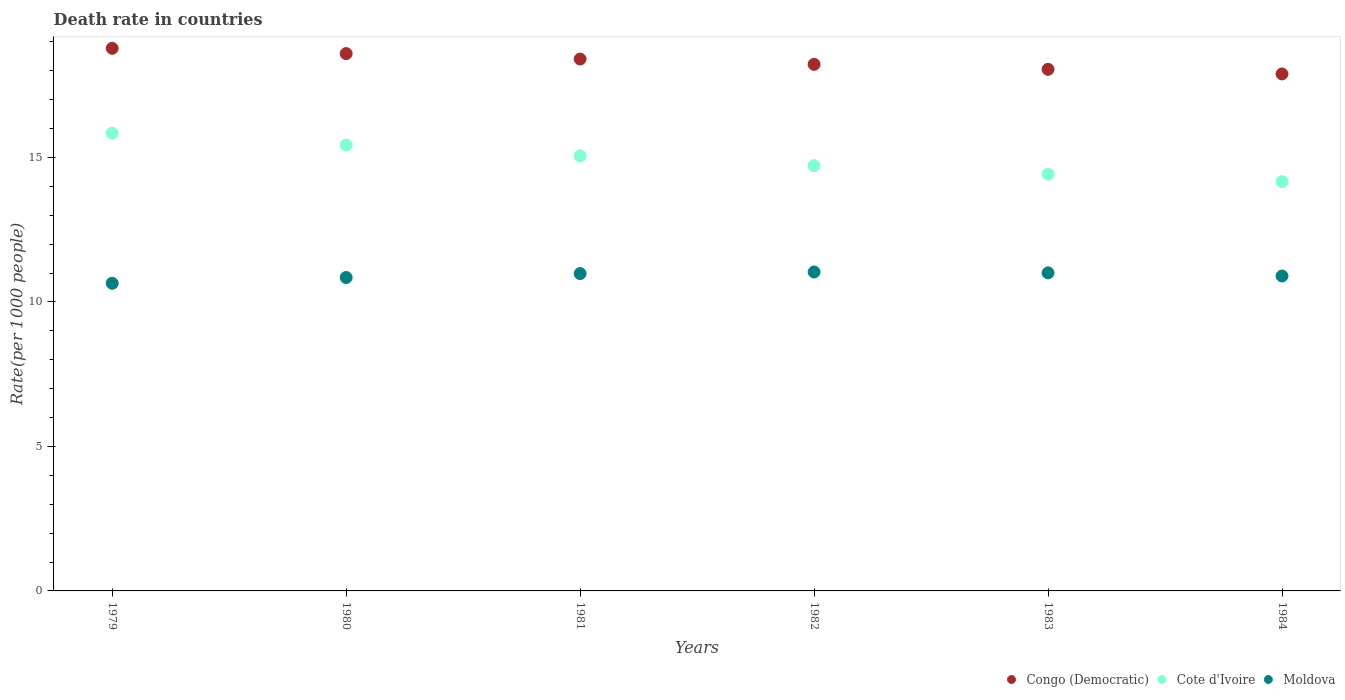How many different coloured dotlines are there?
Offer a very short reply. 3. Across all years, what is the maximum death rate in Congo (Democratic)?
Keep it short and to the point. 18.78. Across all years, what is the minimum death rate in Moldova?
Provide a short and direct response. 10.65. In which year was the death rate in Cote d'Ivoire maximum?
Your response must be concise. 1979. What is the total death rate in Moldova in the graph?
Offer a terse response. 65.43. What is the difference between the death rate in Moldova in 1980 and that in 1982?
Offer a very short reply. -0.19. What is the difference between the death rate in Cote d'Ivoire in 1979 and the death rate in Congo (Democratic) in 1981?
Offer a terse response. -2.57. What is the average death rate in Congo (Democratic) per year?
Provide a succinct answer. 18.33. In the year 1984, what is the difference between the death rate in Moldova and death rate in Congo (Democratic)?
Provide a short and direct response. -6.99. What is the ratio of the death rate in Cote d'Ivoire in 1980 to that in 1981?
Provide a short and direct response. 1.02. Is the difference between the death rate in Moldova in 1981 and 1983 greater than the difference between the death rate in Congo (Democratic) in 1981 and 1983?
Keep it short and to the point. No. What is the difference between the highest and the second highest death rate in Congo (Democratic)?
Offer a very short reply. 0.18. What is the difference between the highest and the lowest death rate in Cote d'Ivoire?
Your answer should be very brief. 1.68. Is it the case that in every year, the sum of the death rate in Congo (Democratic) and death rate in Moldova  is greater than the death rate in Cote d'Ivoire?
Your answer should be compact. Yes. How many dotlines are there?
Make the answer very short. 3. Are the values on the major ticks of Y-axis written in scientific E-notation?
Your response must be concise. No. Does the graph contain grids?
Offer a terse response. No. Where does the legend appear in the graph?
Offer a very short reply. Bottom right. What is the title of the graph?
Give a very brief answer. Death rate in countries. Does "French Polynesia" appear as one of the legend labels in the graph?
Your answer should be very brief. No. What is the label or title of the Y-axis?
Your answer should be compact. Rate(per 1000 people). What is the Rate(per 1000 people) in Congo (Democratic) in 1979?
Your response must be concise. 18.78. What is the Rate(per 1000 people) of Cote d'Ivoire in 1979?
Your answer should be very brief. 15.84. What is the Rate(per 1000 people) of Moldova in 1979?
Your answer should be very brief. 10.65. What is the Rate(per 1000 people) in Congo (Democratic) in 1980?
Provide a succinct answer. 18.6. What is the Rate(per 1000 people) in Cote d'Ivoire in 1980?
Keep it short and to the point. 15.43. What is the Rate(per 1000 people) in Moldova in 1980?
Your response must be concise. 10.85. What is the Rate(per 1000 people) in Congo (Democratic) in 1981?
Offer a very short reply. 18.41. What is the Rate(per 1000 people) in Cote d'Ivoire in 1981?
Make the answer very short. 15.06. What is the Rate(per 1000 people) of Moldova in 1981?
Offer a terse response. 10.98. What is the Rate(per 1000 people) in Congo (Democratic) in 1982?
Ensure brevity in your answer.  18.23. What is the Rate(per 1000 people) of Cote d'Ivoire in 1982?
Your answer should be compact. 14.72. What is the Rate(per 1000 people) of Moldova in 1982?
Your answer should be compact. 11.04. What is the Rate(per 1000 people) in Congo (Democratic) in 1983?
Provide a short and direct response. 18.05. What is the Rate(per 1000 people) in Cote d'Ivoire in 1983?
Make the answer very short. 14.42. What is the Rate(per 1000 people) in Moldova in 1983?
Offer a terse response. 11.01. What is the Rate(per 1000 people) in Congo (Democratic) in 1984?
Offer a very short reply. 17.89. What is the Rate(per 1000 people) of Cote d'Ivoire in 1984?
Make the answer very short. 14.16. Across all years, what is the maximum Rate(per 1000 people) in Congo (Democratic)?
Your answer should be compact. 18.78. Across all years, what is the maximum Rate(per 1000 people) of Cote d'Ivoire?
Offer a terse response. 15.84. Across all years, what is the maximum Rate(per 1000 people) in Moldova?
Your response must be concise. 11.04. Across all years, what is the minimum Rate(per 1000 people) in Congo (Democratic)?
Provide a short and direct response. 17.89. Across all years, what is the minimum Rate(per 1000 people) of Cote d'Ivoire?
Your response must be concise. 14.16. Across all years, what is the minimum Rate(per 1000 people) in Moldova?
Your answer should be very brief. 10.65. What is the total Rate(per 1000 people) of Congo (Democratic) in the graph?
Keep it short and to the point. 109.96. What is the total Rate(per 1000 people) in Cote d'Ivoire in the graph?
Your answer should be compact. 89.64. What is the total Rate(per 1000 people) in Moldova in the graph?
Make the answer very short. 65.43. What is the difference between the Rate(per 1000 people) of Congo (Democratic) in 1979 and that in 1980?
Provide a succinct answer. 0.18. What is the difference between the Rate(per 1000 people) of Cote d'Ivoire in 1979 and that in 1980?
Make the answer very short. 0.41. What is the difference between the Rate(per 1000 people) of Moldova in 1979 and that in 1980?
Offer a very short reply. -0.2. What is the difference between the Rate(per 1000 people) in Congo (Democratic) in 1979 and that in 1981?
Keep it short and to the point. 0.37. What is the difference between the Rate(per 1000 people) in Cote d'Ivoire in 1979 and that in 1981?
Keep it short and to the point. 0.78. What is the difference between the Rate(per 1000 people) in Moldova in 1979 and that in 1981?
Provide a succinct answer. -0.34. What is the difference between the Rate(per 1000 people) of Congo (Democratic) in 1979 and that in 1982?
Offer a terse response. 0.56. What is the difference between the Rate(per 1000 people) of Cote d'Ivoire in 1979 and that in 1982?
Your answer should be compact. 1.12. What is the difference between the Rate(per 1000 people) in Moldova in 1979 and that in 1982?
Provide a short and direct response. -0.39. What is the difference between the Rate(per 1000 people) of Congo (Democratic) in 1979 and that in 1983?
Provide a short and direct response. 0.73. What is the difference between the Rate(per 1000 people) of Cote d'Ivoire in 1979 and that in 1983?
Provide a short and direct response. 1.42. What is the difference between the Rate(per 1000 people) in Moldova in 1979 and that in 1983?
Your answer should be compact. -0.36. What is the difference between the Rate(per 1000 people) of Congo (Democratic) in 1979 and that in 1984?
Provide a short and direct response. 0.89. What is the difference between the Rate(per 1000 people) of Cote d'Ivoire in 1979 and that in 1984?
Your response must be concise. 1.68. What is the difference between the Rate(per 1000 people) in Moldova in 1979 and that in 1984?
Provide a succinct answer. -0.25. What is the difference between the Rate(per 1000 people) of Congo (Democratic) in 1980 and that in 1981?
Offer a very short reply. 0.19. What is the difference between the Rate(per 1000 people) of Cote d'Ivoire in 1980 and that in 1981?
Give a very brief answer. 0.37. What is the difference between the Rate(per 1000 people) of Moldova in 1980 and that in 1981?
Keep it short and to the point. -0.14. What is the difference between the Rate(per 1000 people) of Congo (Democratic) in 1980 and that in 1982?
Offer a very short reply. 0.37. What is the difference between the Rate(per 1000 people) of Cote d'Ivoire in 1980 and that in 1982?
Your answer should be very brief. 0.71. What is the difference between the Rate(per 1000 people) of Moldova in 1980 and that in 1982?
Keep it short and to the point. -0.19. What is the difference between the Rate(per 1000 people) of Congo (Democratic) in 1980 and that in 1983?
Offer a very short reply. 0.54. What is the difference between the Rate(per 1000 people) in Cote d'Ivoire in 1980 and that in 1983?
Offer a terse response. 1.01. What is the difference between the Rate(per 1000 people) in Moldova in 1980 and that in 1983?
Make the answer very short. -0.16. What is the difference between the Rate(per 1000 people) in Congo (Democratic) in 1980 and that in 1984?
Give a very brief answer. 0.7. What is the difference between the Rate(per 1000 people) of Cote d'Ivoire in 1980 and that in 1984?
Provide a short and direct response. 1.27. What is the difference between the Rate(per 1000 people) of Moldova in 1980 and that in 1984?
Offer a terse response. -0.05. What is the difference between the Rate(per 1000 people) in Congo (Democratic) in 1981 and that in 1982?
Your answer should be very brief. 0.18. What is the difference between the Rate(per 1000 people) in Cote d'Ivoire in 1981 and that in 1982?
Keep it short and to the point. 0.34. What is the difference between the Rate(per 1000 people) in Moldova in 1981 and that in 1982?
Your response must be concise. -0.06. What is the difference between the Rate(per 1000 people) in Congo (Democratic) in 1981 and that in 1983?
Provide a succinct answer. 0.36. What is the difference between the Rate(per 1000 people) of Cote d'Ivoire in 1981 and that in 1983?
Provide a succinct answer. 0.64. What is the difference between the Rate(per 1000 people) of Moldova in 1981 and that in 1983?
Offer a terse response. -0.03. What is the difference between the Rate(per 1000 people) in Congo (Democratic) in 1981 and that in 1984?
Offer a very short reply. 0.52. What is the difference between the Rate(per 1000 people) of Cote d'Ivoire in 1981 and that in 1984?
Provide a short and direct response. 0.89. What is the difference between the Rate(per 1000 people) of Moldova in 1981 and that in 1984?
Ensure brevity in your answer.  0.08. What is the difference between the Rate(per 1000 people) of Congo (Democratic) in 1982 and that in 1983?
Offer a very short reply. 0.17. What is the difference between the Rate(per 1000 people) of Cote d'Ivoire in 1982 and that in 1983?
Provide a short and direct response. 0.3. What is the difference between the Rate(per 1000 people) of Moldova in 1982 and that in 1983?
Give a very brief answer. 0.03. What is the difference between the Rate(per 1000 people) in Congo (Democratic) in 1982 and that in 1984?
Ensure brevity in your answer.  0.33. What is the difference between the Rate(per 1000 people) in Cote d'Ivoire in 1982 and that in 1984?
Your response must be concise. 0.56. What is the difference between the Rate(per 1000 people) of Moldova in 1982 and that in 1984?
Ensure brevity in your answer.  0.14. What is the difference between the Rate(per 1000 people) in Congo (Democratic) in 1983 and that in 1984?
Offer a terse response. 0.16. What is the difference between the Rate(per 1000 people) of Cote d'Ivoire in 1983 and that in 1984?
Keep it short and to the point. 0.26. What is the difference between the Rate(per 1000 people) in Moldova in 1983 and that in 1984?
Provide a short and direct response. 0.11. What is the difference between the Rate(per 1000 people) in Congo (Democratic) in 1979 and the Rate(per 1000 people) in Cote d'Ivoire in 1980?
Make the answer very short. 3.35. What is the difference between the Rate(per 1000 people) of Congo (Democratic) in 1979 and the Rate(per 1000 people) of Moldova in 1980?
Your response must be concise. 7.93. What is the difference between the Rate(per 1000 people) in Cote d'Ivoire in 1979 and the Rate(per 1000 people) in Moldova in 1980?
Offer a very short reply. 4.99. What is the difference between the Rate(per 1000 people) of Congo (Democratic) in 1979 and the Rate(per 1000 people) of Cote d'Ivoire in 1981?
Offer a very short reply. 3.72. What is the difference between the Rate(per 1000 people) of Congo (Democratic) in 1979 and the Rate(per 1000 people) of Moldova in 1981?
Your answer should be very brief. 7.8. What is the difference between the Rate(per 1000 people) in Cote d'Ivoire in 1979 and the Rate(per 1000 people) in Moldova in 1981?
Your response must be concise. 4.86. What is the difference between the Rate(per 1000 people) of Congo (Democratic) in 1979 and the Rate(per 1000 people) of Cote d'Ivoire in 1982?
Keep it short and to the point. 4.06. What is the difference between the Rate(per 1000 people) of Congo (Democratic) in 1979 and the Rate(per 1000 people) of Moldova in 1982?
Keep it short and to the point. 7.74. What is the difference between the Rate(per 1000 people) of Cote d'Ivoire in 1979 and the Rate(per 1000 people) of Moldova in 1982?
Offer a very short reply. 4.8. What is the difference between the Rate(per 1000 people) in Congo (Democratic) in 1979 and the Rate(per 1000 people) in Cote d'Ivoire in 1983?
Offer a terse response. 4.36. What is the difference between the Rate(per 1000 people) of Congo (Democratic) in 1979 and the Rate(per 1000 people) of Moldova in 1983?
Offer a very short reply. 7.77. What is the difference between the Rate(per 1000 people) in Cote d'Ivoire in 1979 and the Rate(per 1000 people) in Moldova in 1983?
Provide a succinct answer. 4.83. What is the difference between the Rate(per 1000 people) in Congo (Democratic) in 1979 and the Rate(per 1000 people) in Cote d'Ivoire in 1984?
Provide a succinct answer. 4.62. What is the difference between the Rate(per 1000 people) in Congo (Democratic) in 1979 and the Rate(per 1000 people) in Moldova in 1984?
Provide a short and direct response. 7.88. What is the difference between the Rate(per 1000 people) in Cote d'Ivoire in 1979 and the Rate(per 1000 people) in Moldova in 1984?
Offer a terse response. 4.94. What is the difference between the Rate(per 1000 people) in Congo (Democratic) in 1980 and the Rate(per 1000 people) in Cote d'Ivoire in 1981?
Offer a very short reply. 3.54. What is the difference between the Rate(per 1000 people) of Congo (Democratic) in 1980 and the Rate(per 1000 people) of Moldova in 1981?
Make the answer very short. 7.61. What is the difference between the Rate(per 1000 people) in Cote d'Ivoire in 1980 and the Rate(per 1000 people) in Moldova in 1981?
Offer a terse response. 4.45. What is the difference between the Rate(per 1000 people) in Congo (Democratic) in 1980 and the Rate(per 1000 people) in Cote d'Ivoire in 1982?
Give a very brief answer. 3.88. What is the difference between the Rate(per 1000 people) in Congo (Democratic) in 1980 and the Rate(per 1000 people) in Moldova in 1982?
Ensure brevity in your answer.  7.56. What is the difference between the Rate(per 1000 people) of Cote d'Ivoire in 1980 and the Rate(per 1000 people) of Moldova in 1982?
Provide a succinct answer. 4.39. What is the difference between the Rate(per 1000 people) of Congo (Democratic) in 1980 and the Rate(per 1000 people) of Cote d'Ivoire in 1983?
Ensure brevity in your answer.  4.18. What is the difference between the Rate(per 1000 people) of Congo (Democratic) in 1980 and the Rate(per 1000 people) of Moldova in 1983?
Offer a very short reply. 7.59. What is the difference between the Rate(per 1000 people) of Cote d'Ivoire in 1980 and the Rate(per 1000 people) of Moldova in 1983?
Offer a terse response. 4.42. What is the difference between the Rate(per 1000 people) in Congo (Democratic) in 1980 and the Rate(per 1000 people) in Cote d'Ivoire in 1984?
Your response must be concise. 4.43. What is the difference between the Rate(per 1000 people) of Congo (Democratic) in 1980 and the Rate(per 1000 people) of Moldova in 1984?
Provide a succinct answer. 7.7. What is the difference between the Rate(per 1000 people) in Cote d'Ivoire in 1980 and the Rate(per 1000 people) in Moldova in 1984?
Your answer should be very brief. 4.53. What is the difference between the Rate(per 1000 people) of Congo (Democratic) in 1981 and the Rate(per 1000 people) of Cote d'Ivoire in 1982?
Offer a terse response. 3.69. What is the difference between the Rate(per 1000 people) of Congo (Democratic) in 1981 and the Rate(per 1000 people) of Moldova in 1982?
Provide a short and direct response. 7.37. What is the difference between the Rate(per 1000 people) in Cote d'Ivoire in 1981 and the Rate(per 1000 people) in Moldova in 1982?
Ensure brevity in your answer.  4.02. What is the difference between the Rate(per 1000 people) in Congo (Democratic) in 1981 and the Rate(per 1000 people) in Cote d'Ivoire in 1983?
Provide a succinct answer. 3.99. What is the difference between the Rate(per 1000 people) of Cote d'Ivoire in 1981 and the Rate(per 1000 people) of Moldova in 1983?
Your answer should be compact. 4.05. What is the difference between the Rate(per 1000 people) of Congo (Democratic) in 1981 and the Rate(per 1000 people) of Cote d'Ivoire in 1984?
Provide a short and direct response. 4.24. What is the difference between the Rate(per 1000 people) in Congo (Democratic) in 1981 and the Rate(per 1000 people) in Moldova in 1984?
Offer a terse response. 7.51. What is the difference between the Rate(per 1000 people) of Cote d'Ivoire in 1981 and the Rate(per 1000 people) of Moldova in 1984?
Make the answer very short. 4.16. What is the difference between the Rate(per 1000 people) of Congo (Democratic) in 1982 and the Rate(per 1000 people) of Cote d'Ivoire in 1983?
Your response must be concise. 3.8. What is the difference between the Rate(per 1000 people) in Congo (Democratic) in 1982 and the Rate(per 1000 people) in Moldova in 1983?
Make the answer very short. 7.22. What is the difference between the Rate(per 1000 people) of Cote d'Ivoire in 1982 and the Rate(per 1000 people) of Moldova in 1983?
Your answer should be very brief. 3.71. What is the difference between the Rate(per 1000 people) of Congo (Democratic) in 1982 and the Rate(per 1000 people) of Cote d'Ivoire in 1984?
Your answer should be compact. 4.06. What is the difference between the Rate(per 1000 people) of Congo (Democratic) in 1982 and the Rate(per 1000 people) of Moldova in 1984?
Offer a very short reply. 7.33. What is the difference between the Rate(per 1000 people) in Cote d'Ivoire in 1982 and the Rate(per 1000 people) in Moldova in 1984?
Offer a very short reply. 3.82. What is the difference between the Rate(per 1000 people) of Congo (Democratic) in 1983 and the Rate(per 1000 people) of Cote d'Ivoire in 1984?
Offer a very short reply. 3.89. What is the difference between the Rate(per 1000 people) in Congo (Democratic) in 1983 and the Rate(per 1000 people) in Moldova in 1984?
Ensure brevity in your answer.  7.15. What is the difference between the Rate(per 1000 people) of Cote d'Ivoire in 1983 and the Rate(per 1000 people) of Moldova in 1984?
Your response must be concise. 3.52. What is the average Rate(per 1000 people) in Congo (Democratic) per year?
Ensure brevity in your answer.  18.33. What is the average Rate(per 1000 people) of Cote d'Ivoire per year?
Keep it short and to the point. 14.94. What is the average Rate(per 1000 people) in Moldova per year?
Offer a terse response. 10.9. In the year 1979, what is the difference between the Rate(per 1000 people) in Congo (Democratic) and Rate(per 1000 people) in Cote d'Ivoire?
Provide a short and direct response. 2.94. In the year 1979, what is the difference between the Rate(per 1000 people) of Congo (Democratic) and Rate(per 1000 people) of Moldova?
Make the answer very short. 8.13. In the year 1979, what is the difference between the Rate(per 1000 people) in Cote d'Ivoire and Rate(per 1000 people) in Moldova?
Offer a very short reply. 5.19. In the year 1980, what is the difference between the Rate(per 1000 people) of Congo (Democratic) and Rate(per 1000 people) of Cote d'Ivoire?
Offer a very short reply. 3.17. In the year 1980, what is the difference between the Rate(per 1000 people) in Congo (Democratic) and Rate(per 1000 people) in Moldova?
Make the answer very short. 7.75. In the year 1980, what is the difference between the Rate(per 1000 people) of Cote d'Ivoire and Rate(per 1000 people) of Moldova?
Offer a very short reply. 4.58. In the year 1981, what is the difference between the Rate(per 1000 people) of Congo (Democratic) and Rate(per 1000 people) of Cote d'Ivoire?
Offer a very short reply. 3.35. In the year 1981, what is the difference between the Rate(per 1000 people) of Congo (Democratic) and Rate(per 1000 people) of Moldova?
Your response must be concise. 7.42. In the year 1981, what is the difference between the Rate(per 1000 people) of Cote d'Ivoire and Rate(per 1000 people) of Moldova?
Your answer should be very brief. 4.07. In the year 1982, what is the difference between the Rate(per 1000 people) of Congo (Democratic) and Rate(per 1000 people) of Cote d'Ivoire?
Your response must be concise. 3.5. In the year 1982, what is the difference between the Rate(per 1000 people) of Congo (Democratic) and Rate(per 1000 people) of Moldova?
Ensure brevity in your answer.  7.19. In the year 1982, what is the difference between the Rate(per 1000 people) of Cote d'Ivoire and Rate(per 1000 people) of Moldova?
Provide a succinct answer. 3.68. In the year 1983, what is the difference between the Rate(per 1000 people) in Congo (Democratic) and Rate(per 1000 people) in Cote d'Ivoire?
Offer a very short reply. 3.63. In the year 1983, what is the difference between the Rate(per 1000 people) in Congo (Democratic) and Rate(per 1000 people) in Moldova?
Provide a succinct answer. 7.04. In the year 1983, what is the difference between the Rate(per 1000 people) in Cote d'Ivoire and Rate(per 1000 people) in Moldova?
Give a very brief answer. 3.41. In the year 1984, what is the difference between the Rate(per 1000 people) of Congo (Democratic) and Rate(per 1000 people) of Cote d'Ivoire?
Offer a terse response. 3.73. In the year 1984, what is the difference between the Rate(per 1000 people) of Congo (Democratic) and Rate(per 1000 people) of Moldova?
Keep it short and to the point. 6.99. In the year 1984, what is the difference between the Rate(per 1000 people) of Cote d'Ivoire and Rate(per 1000 people) of Moldova?
Your answer should be very brief. 3.27. What is the ratio of the Rate(per 1000 people) in Congo (Democratic) in 1979 to that in 1980?
Make the answer very short. 1.01. What is the ratio of the Rate(per 1000 people) in Cote d'Ivoire in 1979 to that in 1980?
Keep it short and to the point. 1.03. What is the ratio of the Rate(per 1000 people) of Moldova in 1979 to that in 1980?
Your response must be concise. 0.98. What is the ratio of the Rate(per 1000 people) of Congo (Democratic) in 1979 to that in 1981?
Provide a succinct answer. 1.02. What is the ratio of the Rate(per 1000 people) in Cote d'Ivoire in 1979 to that in 1981?
Provide a short and direct response. 1.05. What is the ratio of the Rate(per 1000 people) of Moldova in 1979 to that in 1981?
Provide a short and direct response. 0.97. What is the ratio of the Rate(per 1000 people) of Congo (Democratic) in 1979 to that in 1982?
Your answer should be compact. 1.03. What is the ratio of the Rate(per 1000 people) of Cote d'Ivoire in 1979 to that in 1982?
Provide a short and direct response. 1.08. What is the ratio of the Rate(per 1000 people) in Moldova in 1979 to that in 1982?
Offer a very short reply. 0.96. What is the ratio of the Rate(per 1000 people) of Congo (Democratic) in 1979 to that in 1983?
Ensure brevity in your answer.  1.04. What is the ratio of the Rate(per 1000 people) in Cote d'Ivoire in 1979 to that in 1983?
Provide a short and direct response. 1.1. What is the ratio of the Rate(per 1000 people) of Moldova in 1979 to that in 1983?
Keep it short and to the point. 0.97. What is the ratio of the Rate(per 1000 people) in Congo (Democratic) in 1979 to that in 1984?
Ensure brevity in your answer.  1.05. What is the ratio of the Rate(per 1000 people) in Cote d'Ivoire in 1979 to that in 1984?
Make the answer very short. 1.12. What is the ratio of the Rate(per 1000 people) of Moldova in 1979 to that in 1984?
Provide a short and direct response. 0.98. What is the ratio of the Rate(per 1000 people) of Congo (Democratic) in 1980 to that in 1981?
Provide a short and direct response. 1.01. What is the ratio of the Rate(per 1000 people) in Cote d'Ivoire in 1980 to that in 1981?
Ensure brevity in your answer.  1.02. What is the ratio of the Rate(per 1000 people) in Moldova in 1980 to that in 1981?
Keep it short and to the point. 0.99. What is the ratio of the Rate(per 1000 people) of Congo (Democratic) in 1980 to that in 1982?
Give a very brief answer. 1.02. What is the ratio of the Rate(per 1000 people) of Cote d'Ivoire in 1980 to that in 1982?
Ensure brevity in your answer.  1.05. What is the ratio of the Rate(per 1000 people) in Moldova in 1980 to that in 1982?
Your answer should be very brief. 0.98. What is the ratio of the Rate(per 1000 people) of Congo (Democratic) in 1980 to that in 1983?
Offer a terse response. 1.03. What is the ratio of the Rate(per 1000 people) in Cote d'Ivoire in 1980 to that in 1983?
Offer a terse response. 1.07. What is the ratio of the Rate(per 1000 people) in Moldova in 1980 to that in 1983?
Your answer should be very brief. 0.99. What is the ratio of the Rate(per 1000 people) in Congo (Democratic) in 1980 to that in 1984?
Make the answer very short. 1.04. What is the ratio of the Rate(per 1000 people) of Cote d'Ivoire in 1980 to that in 1984?
Offer a very short reply. 1.09. What is the ratio of the Rate(per 1000 people) of Moldova in 1980 to that in 1984?
Keep it short and to the point. 1. What is the ratio of the Rate(per 1000 people) in Cote d'Ivoire in 1981 to that in 1982?
Your response must be concise. 1.02. What is the ratio of the Rate(per 1000 people) of Congo (Democratic) in 1981 to that in 1983?
Ensure brevity in your answer.  1.02. What is the ratio of the Rate(per 1000 people) in Cote d'Ivoire in 1981 to that in 1983?
Your answer should be very brief. 1.04. What is the ratio of the Rate(per 1000 people) of Moldova in 1981 to that in 1983?
Your answer should be compact. 1. What is the ratio of the Rate(per 1000 people) in Congo (Democratic) in 1981 to that in 1984?
Provide a succinct answer. 1.03. What is the ratio of the Rate(per 1000 people) in Cote d'Ivoire in 1981 to that in 1984?
Ensure brevity in your answer.  1.06. What is the ratio of the Rate(per 1000 people) of Moldova in 1981 to that in 1984?
Offer a very short reply. 1.01. What is the ratio of the Rate(per 1000 people) of Congo (Democratic) in 1982 to that in 1983?
Ensure brevity in your answer.  1.01. What is the ratio of the Rate(per 1000 people) of Cote d'Ivoire in 1982 to that in 1983?
Ensure brevity in your answer.  1.02. What is the ratio of the Rate(per 1000 people) in Moldova in 1982 to that in 1983?
Your response must be concise. 1. What is the ratio of the Rate(per 1000 people) of Congo (Democratic) in 1982 to that in 1984?
Offer a terse response. 1.02. What is the ratio of the Rate(per 1000 people) in Cote d'Ivoire in 1982 to that in 1984?
Your answer should be very brief. 1.04. What is the ratio of the Rate(per 1000 people) in Moldova in 1982 to that in 1984?
Give a very brief answer. 1.01. What is the ratio of the Rate(per 1000 people) of Congo (Democratic) in 1983 to that in 1984?
Provide a succinct answer. 1.01. What is the ratio of the Rate(per 1000 people) in Cote d'Ivoire in 1983 to that in 1984?
Your response must be concise. 1.02. What is the ratio of the Rate(per 1000 people) in Moldova in 1983 to that in 1984?
Make the answer very short. 1.01. What is the difference between the highest and the second highest Rate(per 1000 people) in Congo (Democratic)?
Your answer should be compact. 0.18. What is the difference between the highest and the second highest Rate(per 1000 people) of Cote d'Ivoire?
Offer a terse response. 0.41. What is the difference between the highest and the second highest Rate(per 1000 people) of Moldova?
Keep it short and to the point. 0.03. What is the difference between the highest and the lowest Rate(per 1000 people) in Congo (Democratic)?
Your response must be concise. 0.89. What is the difference between the highest and the lowest Rate(per 1000 people) of Cote d'Ivoire?
Your answer should be very brief. 1.68. What is the difference between the highest and the lowest Rate(per 1000 people) in Moldova?
Offer a very short reply. 0.39. 